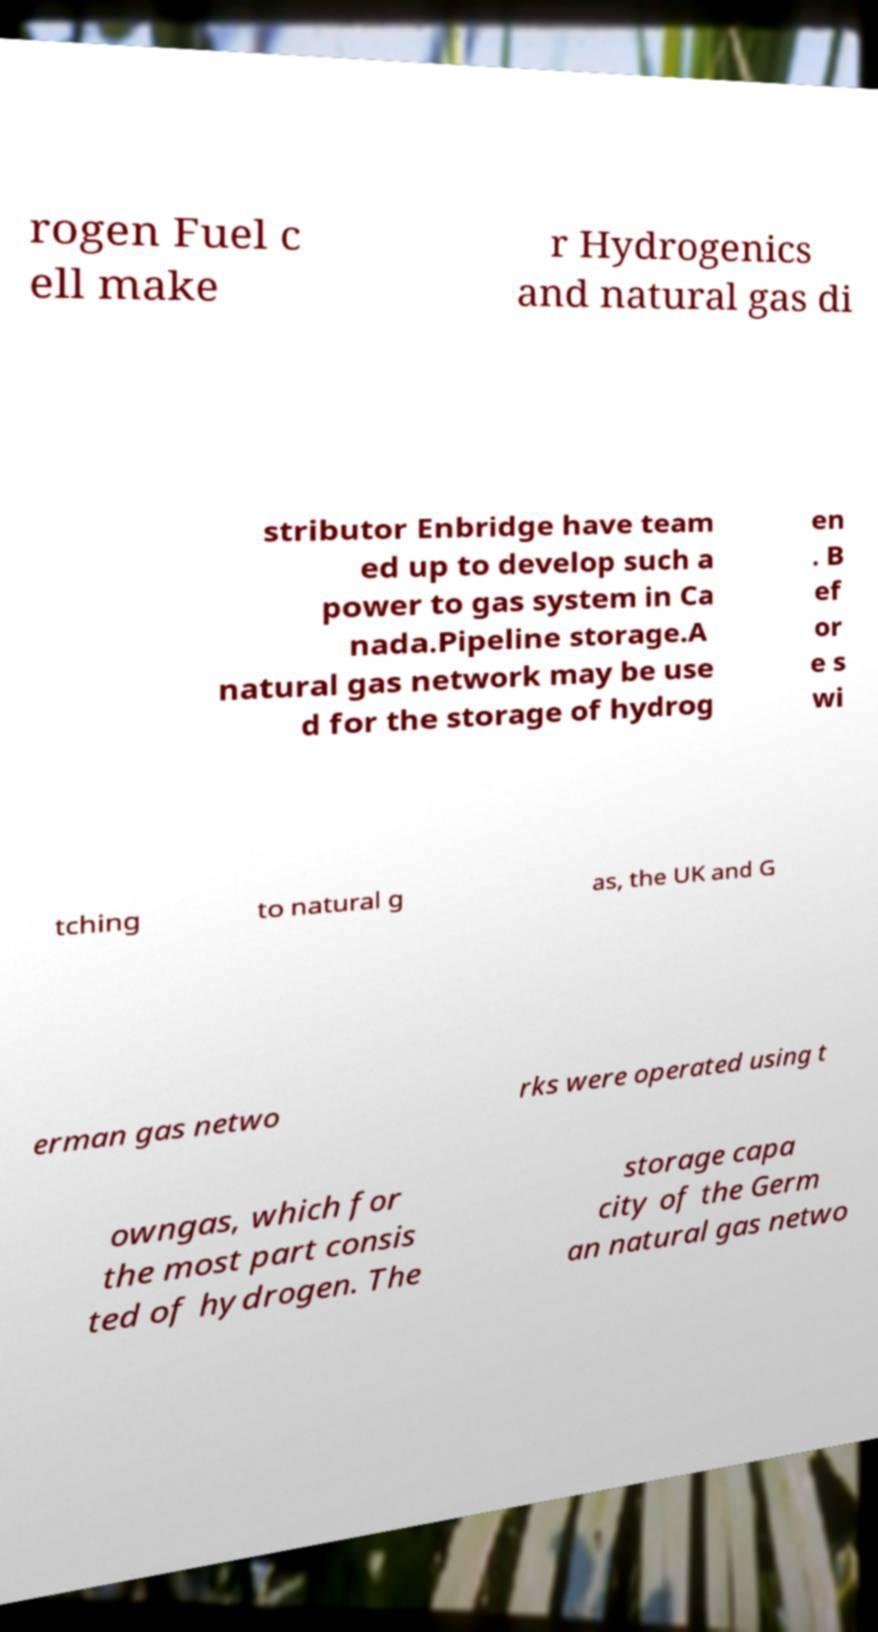Can you read and provide the text displayed in the image?This photo seems to have some interesting text. Can you extract and type it out for me? rogen Fuel c ell make r Hydrogenics and natural gas di stributor Enbridge have team ed up to develop such a power to gas system in Ca nada.Pipeline storage.A natural gas network may be use d for the storage of hydrog en . B ef or e s wi tching to natural g as, the UK and G erman gas netwo rks were operated using t owngas, which for the most part consis ted of hydrogen. The storage capa city of the Germ an natural gas netwo 